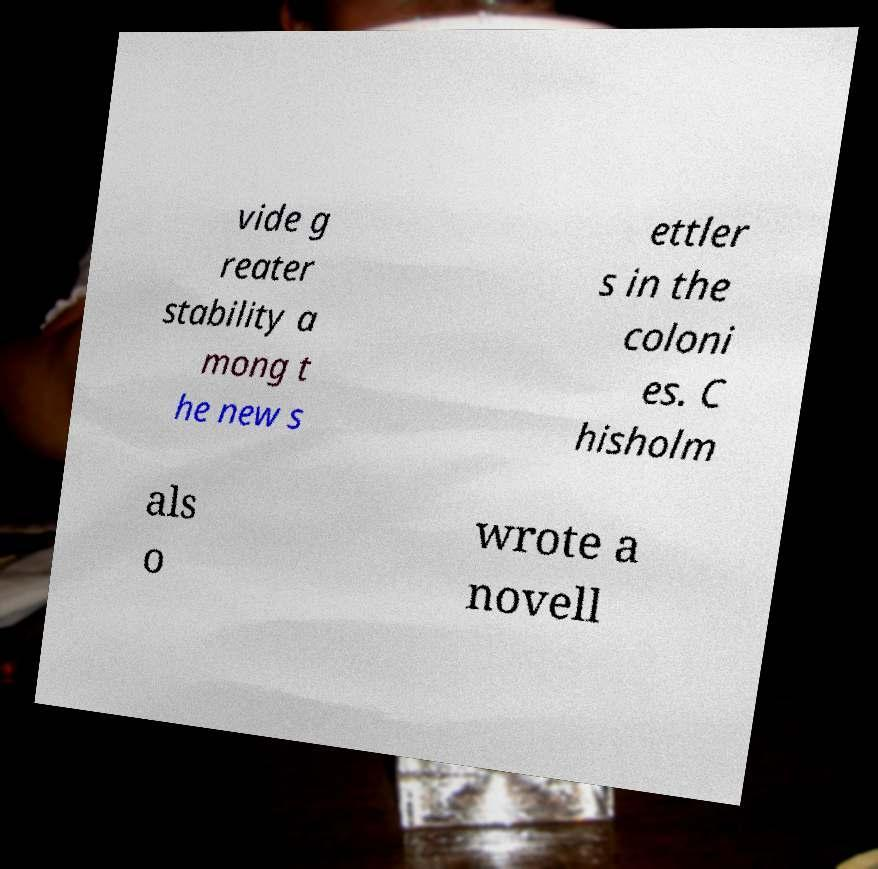What messages or text are displayed in this image? I need them in a readable, typed format. vide g reater stability a mong t he new s ettler s in the coloni es. C hisholm als o wrote a novell 